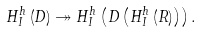<formula> <loc_0><loc_0><loc_500><loc_500>H _ { I } ^ { h } \left ( D \right ) \twoheadrightarrow H _ { I } ^ { h } \left ( D \left ( H _ { I } ^ { h } \left ( R \right ) \right ) \right ) .</formula> 